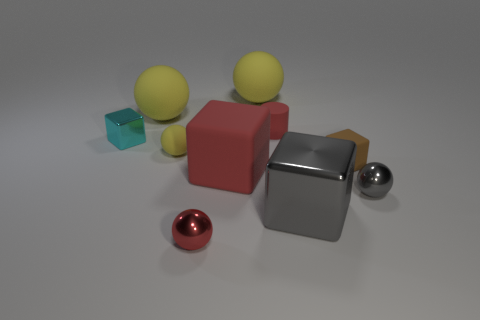Subtract all green cubes. How many yellow balls are left? 3 Subtract 1 spheres. How many spheres are left? 4 Subtract all red balls. How many balls are left? 4 Subtract all red metal spheres. How many spheres are left? 4 Subtract all brown spheres. Subtract all yellow blocks. How many spheres are left? 5 Subtract all blocks. How many objects are left? 6 Subtract 0 blue balls. How many objects are left? 10 Subtract all big red blocks. Subtract all big rubber cubes. How many objects are left? 8 Add 2 large shiny cubes. How many large shiny cubes are left? 3 Add 5 small green shiny cubes. How many small green shiny cubes exist? 5 